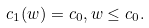<formula> <loc_0><loc_0><loc_500><loc_500>c _ { 1 } ( w ) = c _ { 0 } , w \leq c _ { 0 } .</formula> 